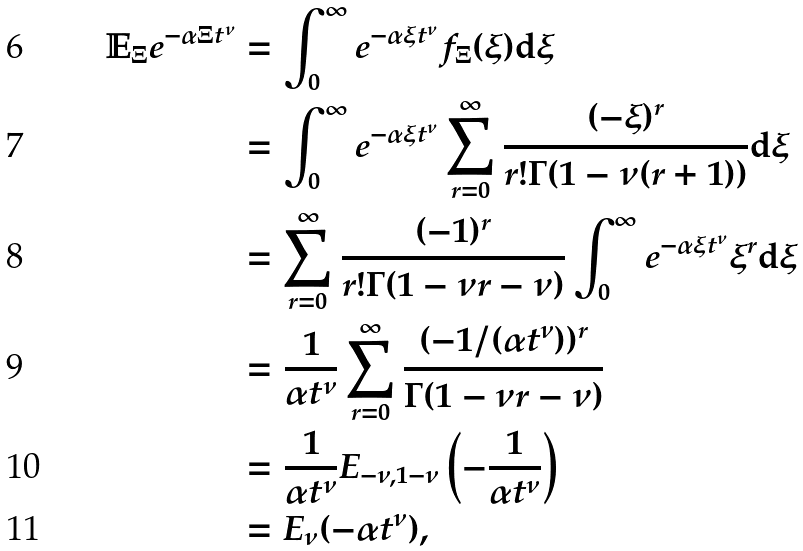<formula> <loc_0><loc_0><loc_500><loc_500>\mathbb { E } _ { \Xi } e ^ { - \alpha \Xi t ^ { \nu } } & = \int _ { 0 } ^ { \infty } e ^ { - \alpha \xi t ^ { \nu } } f _ { \Xi } ( \xi ) \mathrm d \xi \\ & = \int _ { 0 } ^ { \infty } e ^ { - \alpha \xi t ^ { \nu } } \sum _ { r = 0 } ^ { \infty } \frac { ( - \xi ) ^ { r } } { r ! \Gamma ( 1 - \nu ( r + 1 ) ) } \mathrm d \xi \\ & = \sum _ { r = 0 } ^ { \infty } \frac { ( - 1 ) ^ { r } } { r ! \Gamma ( 1 - \nu r - \nu ) } \int _ { 0 } ^ { \infty } e ^ { - \alpha \xi t ^ { \nu } } \xi ^ { r } \mathrm d \xi \\ & = \frac { 1 } { \alpha t ^ { \nu } } \sum _ { r = 0 } ^ { \infty } \frac { ( - 1 / ( \alpha t ^ { \nu } ) ) ^ { r } } { \Gamma ( 1 - \nu r - \nu ) } \\ & = \frac { 1 } { \alpha t ^ { \nu } } E _ { - \nu , 1 - \nu } \left ( - \frac { 1 } { \alpha t ^ { \nu } } \right ) \\ & = E _ { \nu } ( - \alpha t ^ { \nu } ) ,</formula> 